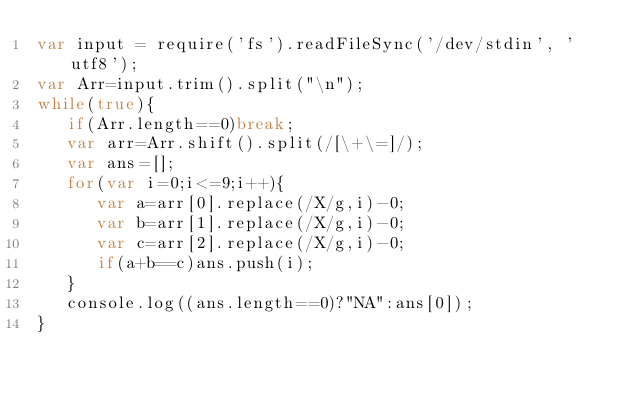Convert code to text. <code><loc_0><loc_0><loc_500><loc_500><_JavaScript_>var input = require('fs').readFileSync('/dev/stdin', 'utf8');
var Arr=input.trim().split("\n");
while(true){
   if(Arr.length==0)break;
   var arr=Arr.shift().split(/[\+\=]/);
   var ans=[];
   for(var i=0;i<=9;i++){
      var a=arr[0].replace(/X/g,i)-0;
      var b=arr[1].replace(/X/g,i)-0;
      var c=arr[2].replace(/X/g,i)-0;
      if(a+b==c)ans.push(i);
   }
   console.log((ans.length==0)?"NA":ans[0]);
}</code> 